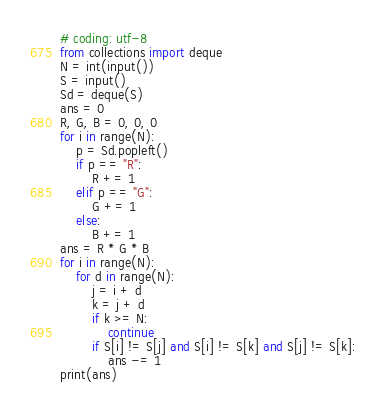<code> <loc_0><loc_0><loc_500><loc_500><_Python_># coding: utf-8
from collections import deque
N = int(input())
S = input()
Sd = deque(S)
ans = 0
R, G, B = 0, 0, 0
for i in range(N):
    p = Sd.popleft()
    if p == "R":
        R += 1
    elif p == "G":
        G += 1
    else:
        B += 1
ans = R * G * B
for i in range(N):
    for d in range(N):
        j = i + d
        k = j + d
        if k >= N:
            continue
        if S[i] != S[j] and S[i] != S[k] and S[j] != S[k]:
            ans -= 1
print(ans)</code> 